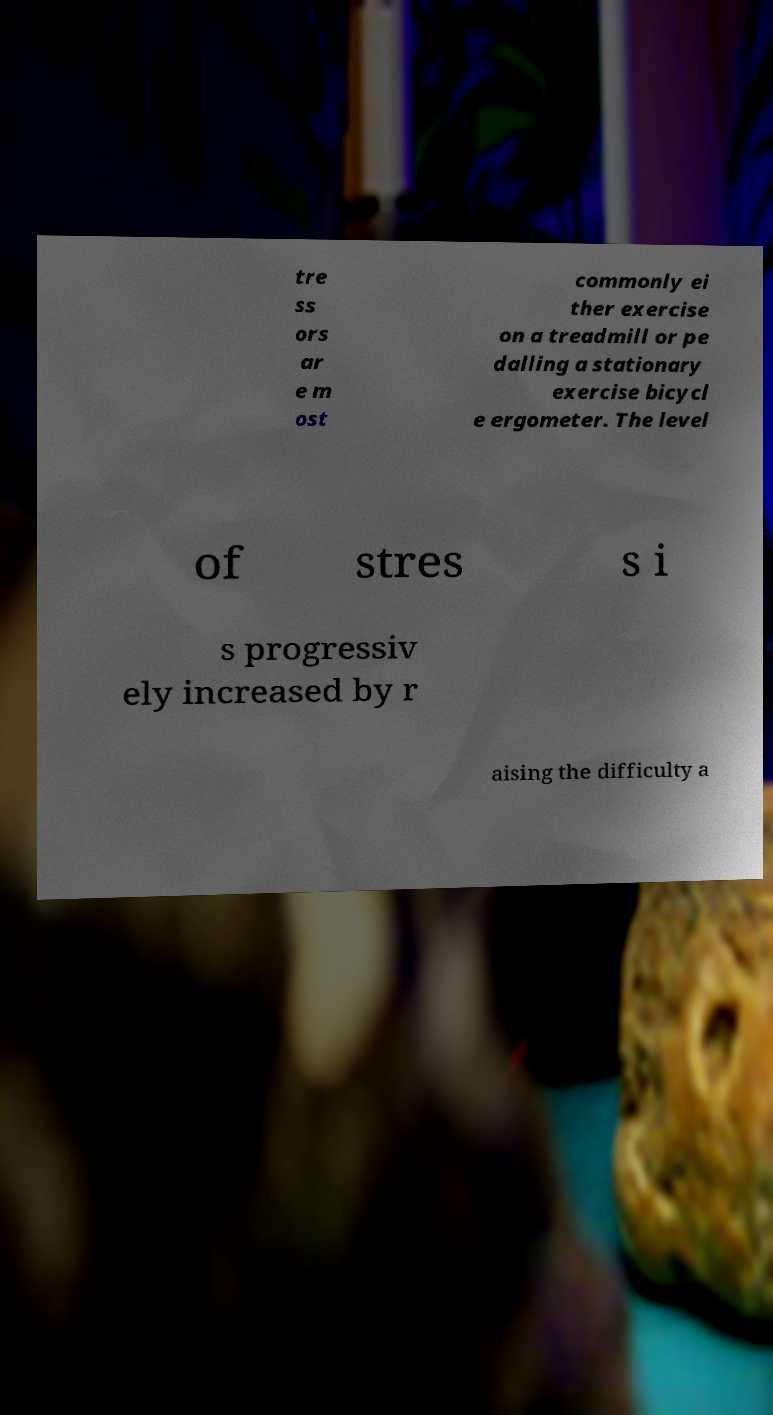Can you accurately transcribe the text from the provided image for me? tre ss ors ar e m ost commonly ei ther exercise on a treadmill or pe dalling a stationary exercise bicycl e ergometer. The level of stres s i s progressiv ely increased by r aising the difficulty a 